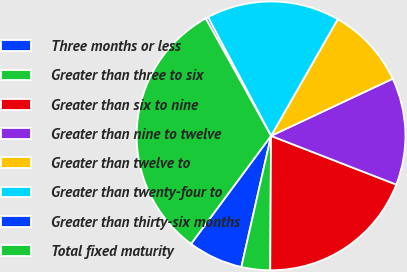<chart> <loc_0><loc_0><loc_500><loc_500><pie_chart><fcel>Three months or less<fcel>Greater than three to six<fcel>Greater than six to nine<fcel>Greater than nine to twelve<fcel>Greater than twelve to<fcel>Greater than twenty-four to<fcel>Greater than thirty-six months<fcel>Total fixed maturity<nl><fcel>6.6%<fcel>3.45%<fcel>19.19%<fcel>12.89%<fcel>9.75%<fcel>16.04%<fcel>0.3%<fcel>31.78%<nl></chart> 